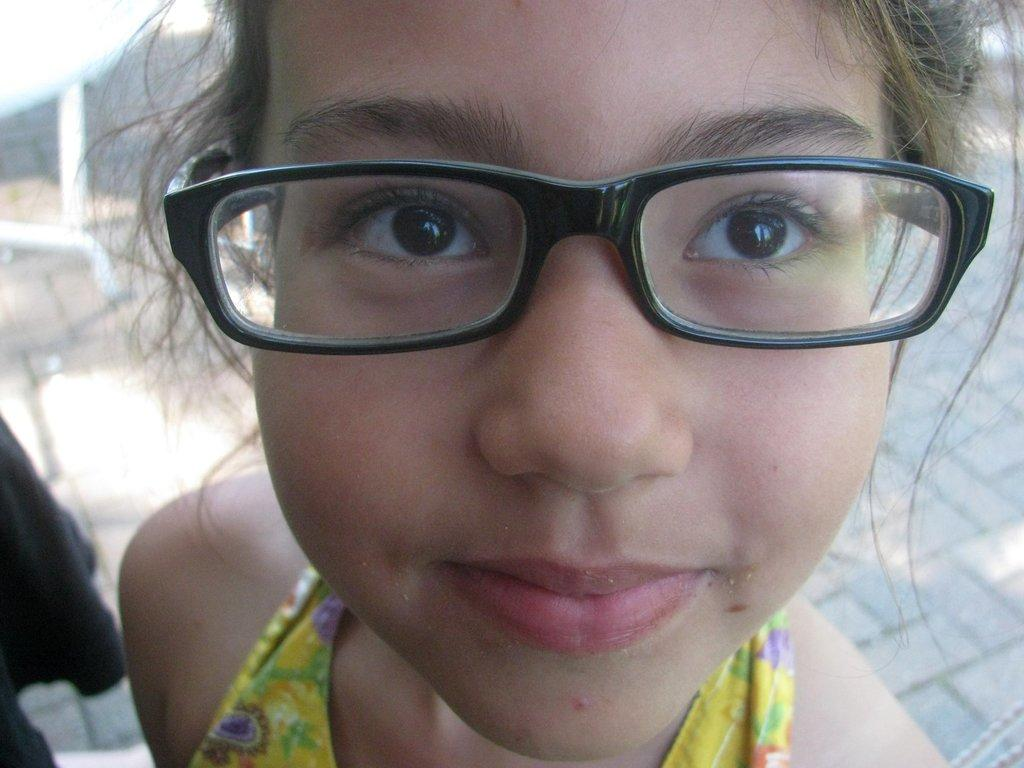Who is the main subject in the image? There is a girl in the image. What is the girl wearing in the image? The girl is wearing spectacles. What type of teeth can be seen in the image? There are no teeth visible in the image, as it features a girl wearing spectacles. 